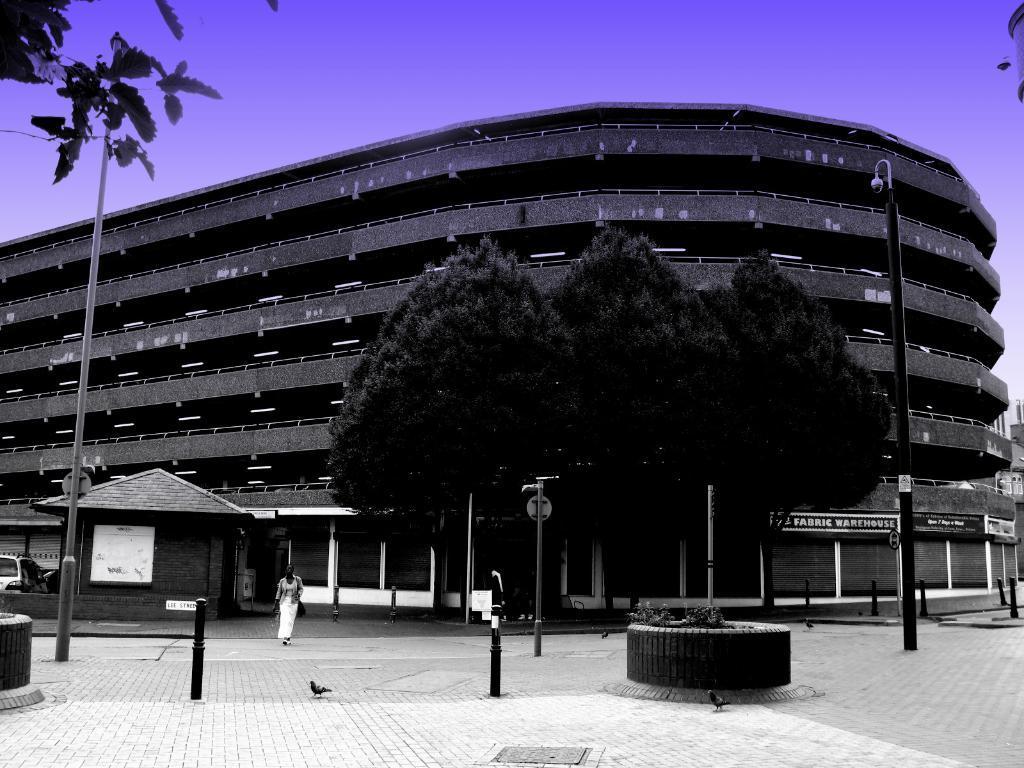Could you give a brief overview of what you see in this image? In this image we can see a few buildings, there are some poles, birds, trees, lights, boards, plants and vehicles, in the background we can see the sky. 